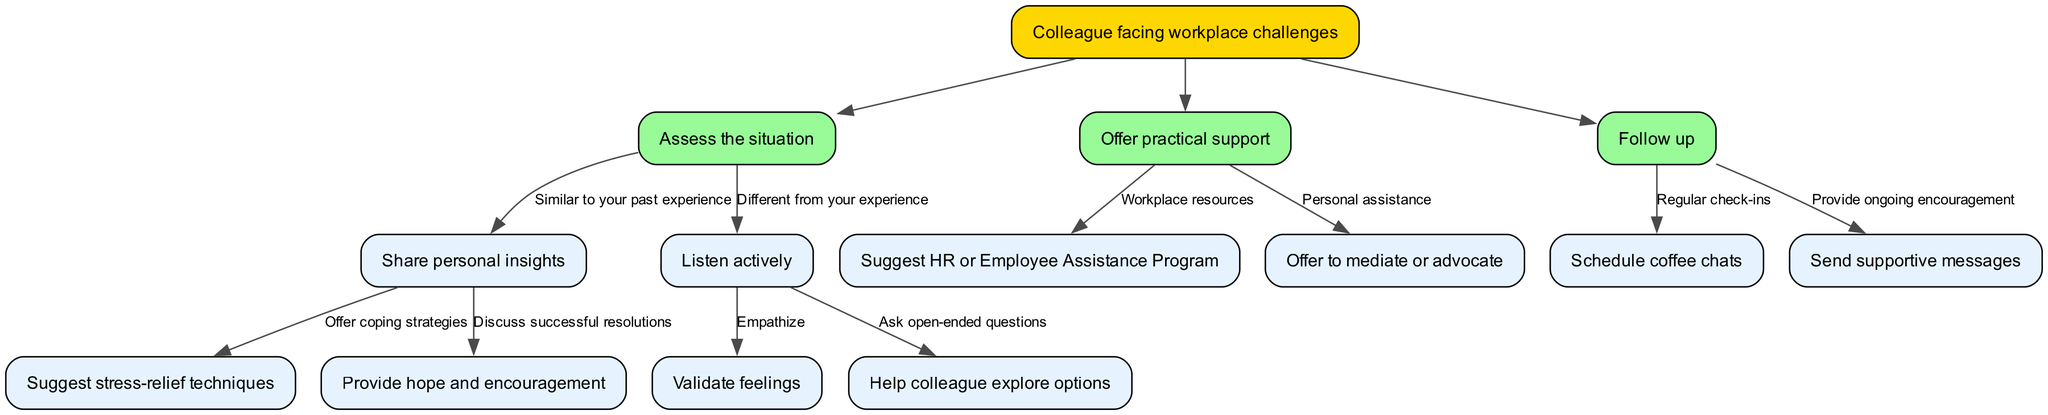What is the root node of this decision tree? The root node is "Colleague facing workplace challenges," which can be identified at the top of the diagram as the main starting point for decision-making.
Answer: Colleague facing workplace challenges How many decision nodes are present in the diagram? There are three decision nodes in the diagram: "Assess the situation," "Offer practical support," and "Follow up." Each represents a step in the decision-making process.
Answer: 3 What action is suggested when a colleague's situation is similar to your past experience? The action suggested is "Share personal insights," which is a direct follow-up to the decision made at the "Assess the situation" node.
Answer: Share personal insights What is the next step after listening actively when the situation is different from your experience? After listening actively, the next step is to "Help colleague explore options," which is derived from asking open-ended questions at the "Listen actively" node.
Answer: Help colleague explore options Which option leads to providing ongoing support after offering practical support? The option that leads to providing ongoing support is "Send supportive messages," which can be identified as part of the follow-up process after practical support steps.
Answer: Send supportive messages What does the node "Suggest HR or Employee Assistance Program" represent? This node represents an option for offering practical support specifically related to workplace resources, as indicated under the "Offer practical support" decision node.
Answer: Suggest HR or Employee Assistance Program How many edges are coming out of the "Assess the situation" node? There are two edges coming out of the "Assess the situation" node, which branch into different scenarios based on whether the situation is similar to or different from one's past experience.
Answer: 2 What should you do after suggesting stress-relief techniques? After suggesting stress-relief techniques, the next action is to "Provide hope and encouragement," which follows the logical flow of supporting the colleague with additional positive reinforcement.
Answer: Provide hope and encouragement What type of questions should be asked when listening actively? When listening actively, the questions should be open-ended, as indicated in the decision path that guides support strategies when the colleague's situation differs from yours.
Answer: Ask open-ended questions 